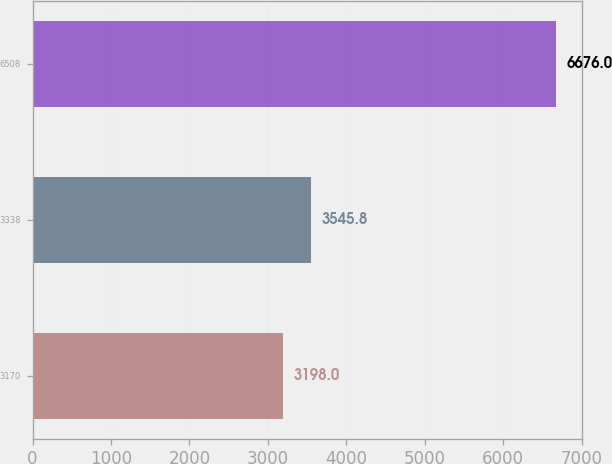Convert chart. <chart><loc_0><loc_0><loc_500><loc_500><bar_chart><fcel>3170<fcel>3338<fcel>6508<nl><fcel>3198<fcel>3545.8<fcel>6676<nl></chart> 